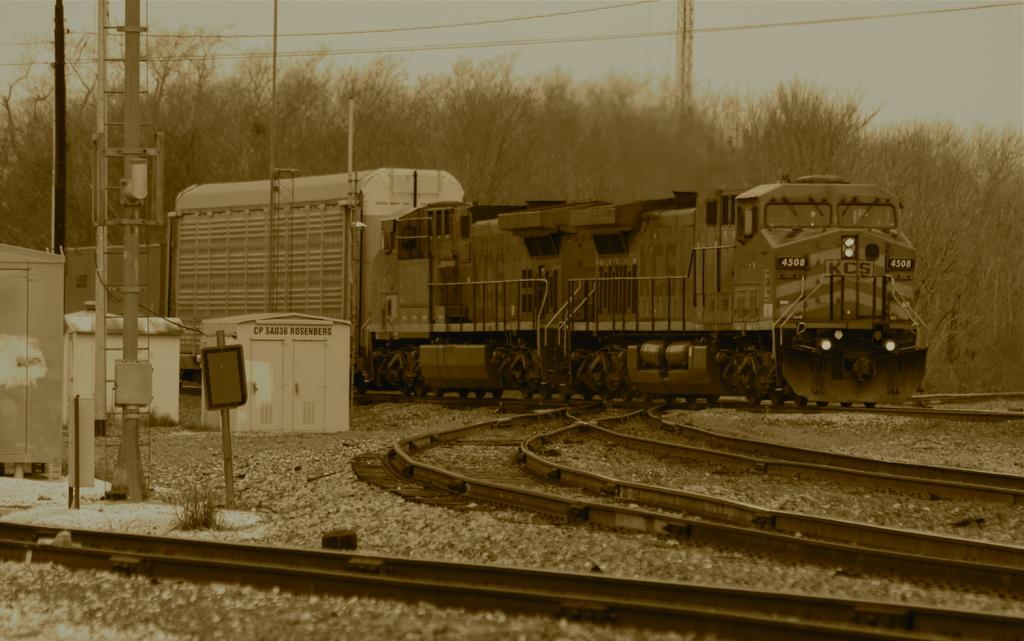What type of vegetation can be seen in the image? There are trees in the image. What structures are present in the image that are related to power or communication? There are poles with wires and power supply boxes in the image. What type of transportation is visible in the image? There is a train in the image. What additional feature can be seen in the image related to the train? There are tracks in the image. What is the purpose of the stand in the image? The purpose of the stand is not specified in the image, but it could be used for various purposes such as holding signs or equipment. What is visible at the top of the image? The sky is visible at the top of the image. Who is the manager of the train in the image? There is no indication of a manager or any personnel in the image; it only shows the train, tracks, and related infrastructure. 